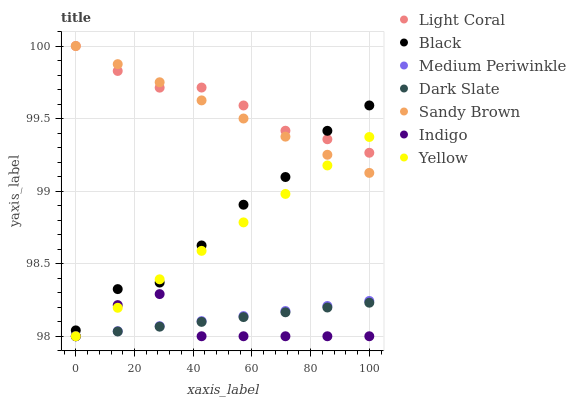Does Indigo have the minimum area under the curve?
Answer yes or no. Yes. Does Light Coral have the maximum area under the curve?
Answer yes or no. Yes. Does Medium Periwinkle have the minimum area under the curve?
Answer yes or no. No. Does Medium Periwinkle have the maximum area under the curve?
Answer yes or no. No. Is Dark Slate the smoothest?
Answer yes or no. Yes. Is Black the roughest?
Answer yes or no. Yes. Is Medium Periwinkle the smoothest?
Answer yes or no. No. Is Medium Periwinkle the roughest?
Answer yes or no. No. Does Indigo have the lowest value?
Answer yes or no. Yes. Does Light Coral have the lowest value?
Answer yes or no. No. Does Sandy Brown have the highest value?
Answer yes or no. Yes. Does Medium Periwinkle have the highest value?
Answer yes or no. No. Is Dark Slate less than Sandy Brown?
Answer yes or no. Yes. Is Black greater than Medium Periwinkle?
Answer yes or no. Yes. Does Medium Periwinkle intersect Yellow?
Answer yes or no. Yes. Is Medium Periwinkle less than Yellow?
Answer yes or no. No. Is Medium Periwinkle greater than Yellow?
Answer yes or no. No. Does Dark Slate intersect Sandy Brown?
Answer yes or no. No. 